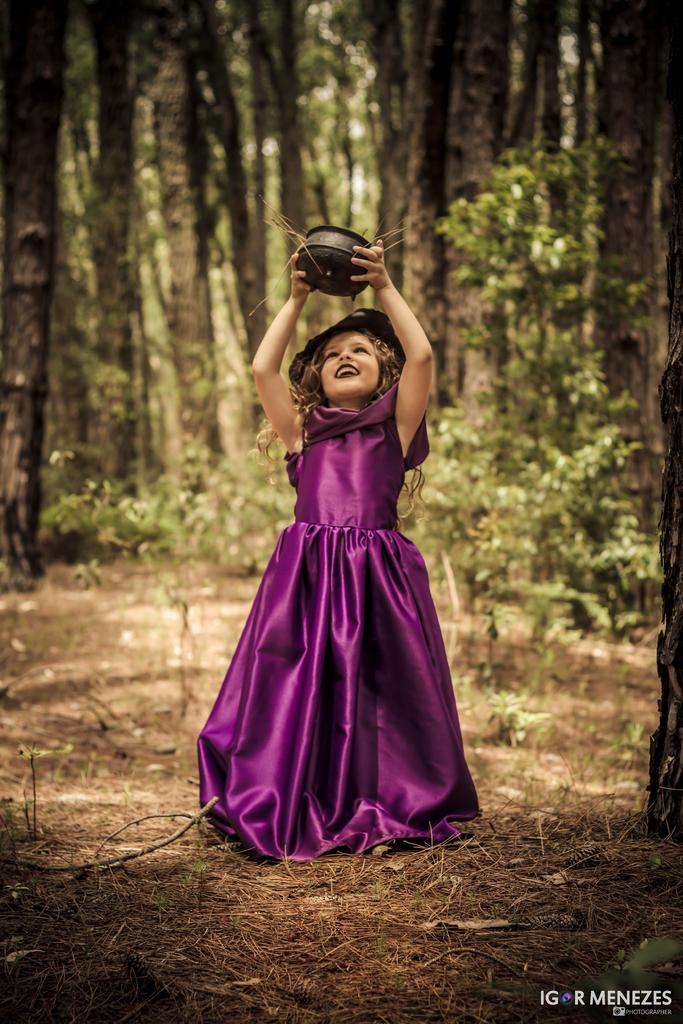Who is the main subject in the image? There is a small girl in the image. What is the girl wearing? The girl is wearing a purple dress. Where is the girl standing? The girl is standing in a forest. What is the girl holding in her hand? The girl is holding a black bowl in her hand. What can be seen in the background of the image? There are tall trees in the background of the image. How many square zinc bikes are present in the image? There are no square zinc bikes present in the image. 